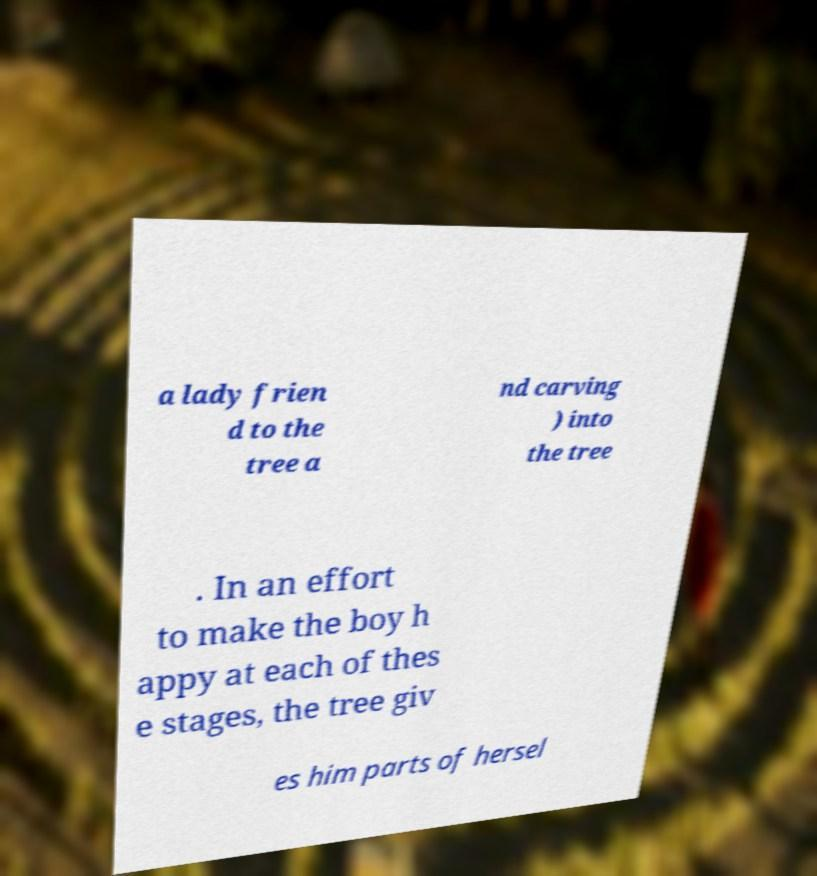Could you assist in decoding the text presented in this image and type it out clearly? a lady frien d to the tree a nd carving ) into the tree . In an effort to make the boy h appy at each of thes e stages, the tree giv es him parts of hersel 